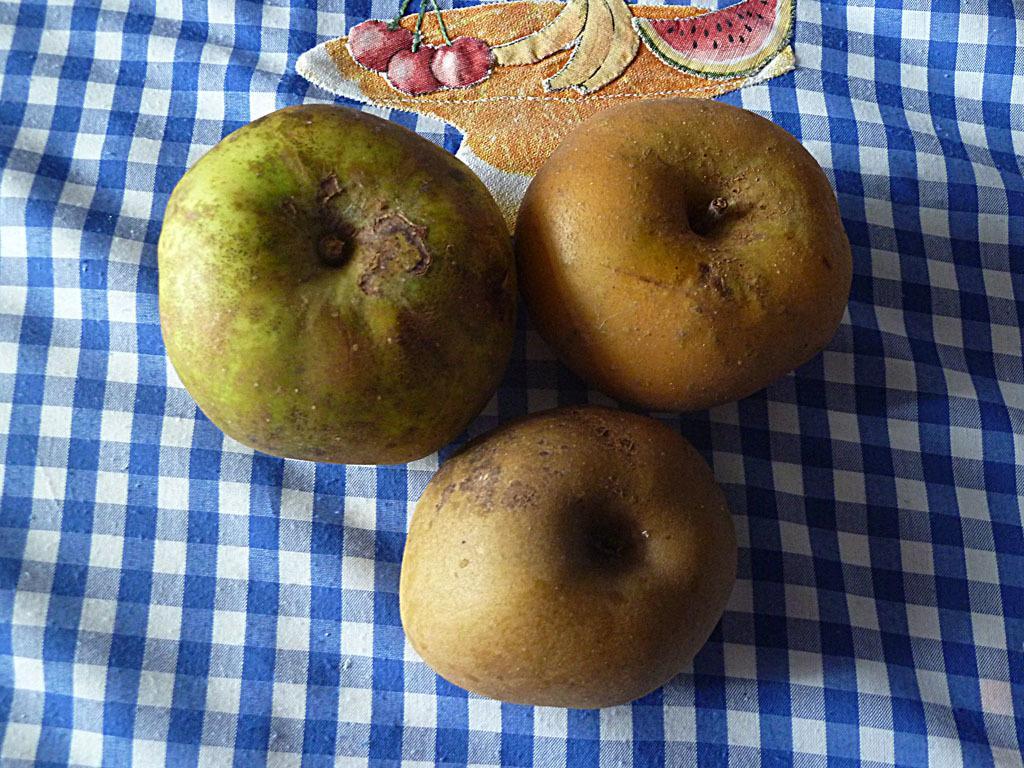Can you describe this image briefly? In this image we can see fruits on a cloth. On the cloth there is an embroidery of fruits. 